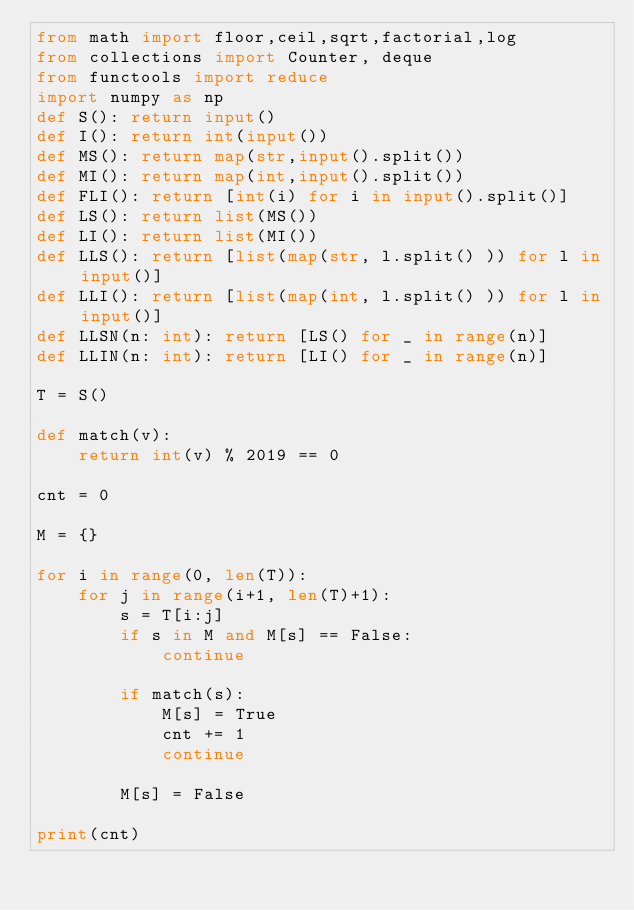<code> <loc_0><loc_0><loc_500><loc_500><_Python_>from math import floor,ceil,sqrt,factorial,log
from collections import Counter, deque
from functools import reduce
import numpy as np
def S(): return input()
def I(): return int(input())
def MS(): return map(str,input().split())
def MI(): return map(int,input().split())
def FLI(): return [int(i) for i in input().split()]
def LS(): return list(MS())
def LI(): return list(MI())
def LLS(): return [list(map(str, l.split() )) for l in input()]
def LLI(): return [list(map(int, l.split() )) for l in input()]
def LLSN(n: int): return [LS() for _ in range(n)]
def LLIN(n: int): return [LI() for _ in range(n)]

T = S()

def match(v):
    return int(v) % 2019 == 0

cnt = 0

M = {}

for i in range(0, len(T)):
    for j in range(i+1, len(T)+1):
        s = T[i:j]
        if s in M and M[s] == False:
            continue

        if match(s):
            M[s] = True
            cnt += 1
            continue

        M[s] = False

print(cnt)</code> 